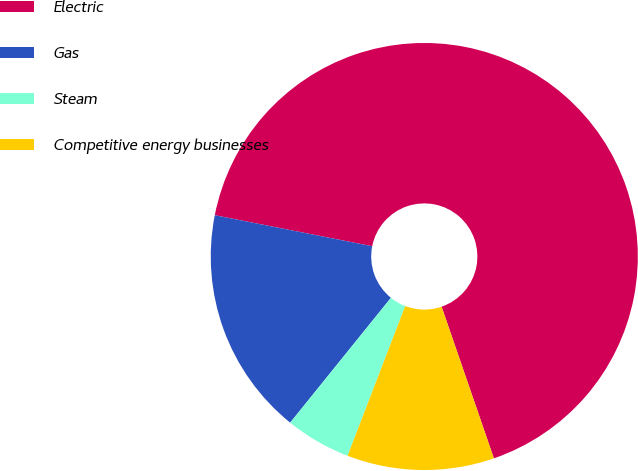Convert chart. <chart><loc_0><loc_0><loc_500><loc_500><pie_chart><fcel>Electric<fcel>Gas<fcel>Steam<fcel>Competitive energy businesses<nl><fcel>66.62%<fcel>17.29%<fcel>4.96%<fcel>11.13%<nl></chart> 